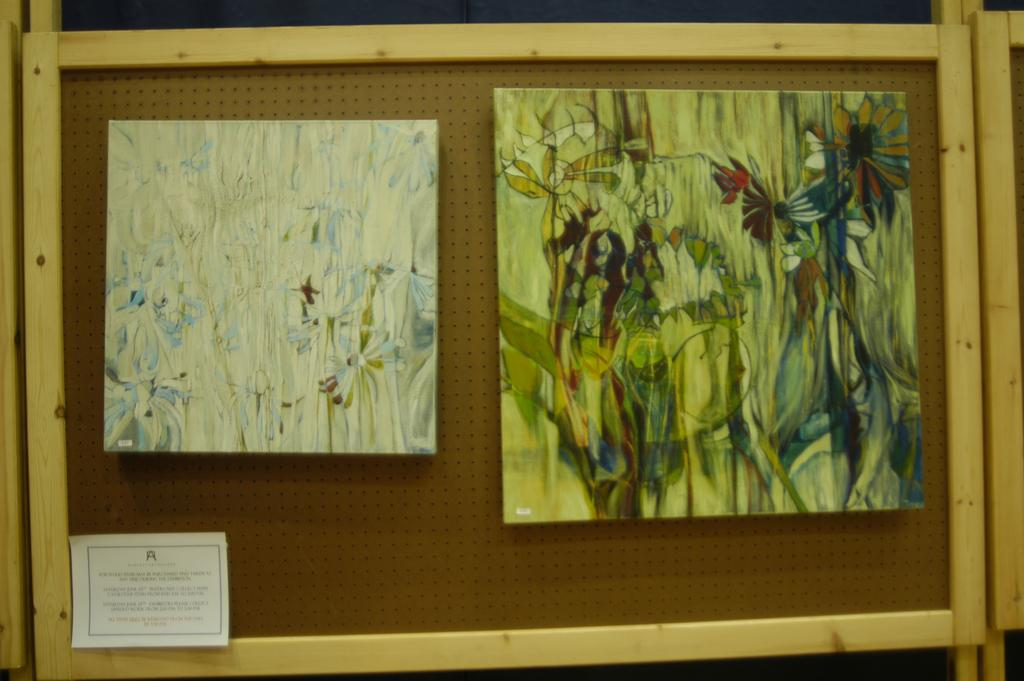What is the color of the notice in the image? The notice in the image is brown-colored. What is attached to the notice in the image? There are two painting frames hanging on the notice. What type of plough is depicted in the painting frames on the notice? There is no plough depicted in the painting frames on the notice; they are empty frames. What type of battle is taking place in the image? There is no battle depicted in the image; it only features a brown-colored notice with two painting frames. 